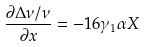Convert formula to latex. <formula><loc_0><loc_0><loc_500><loc_500>\frac { \partial \Delta \nu / \nu } { \partial x } = - 1 6 \gamma _ { 1 } \alpha X</formula> 